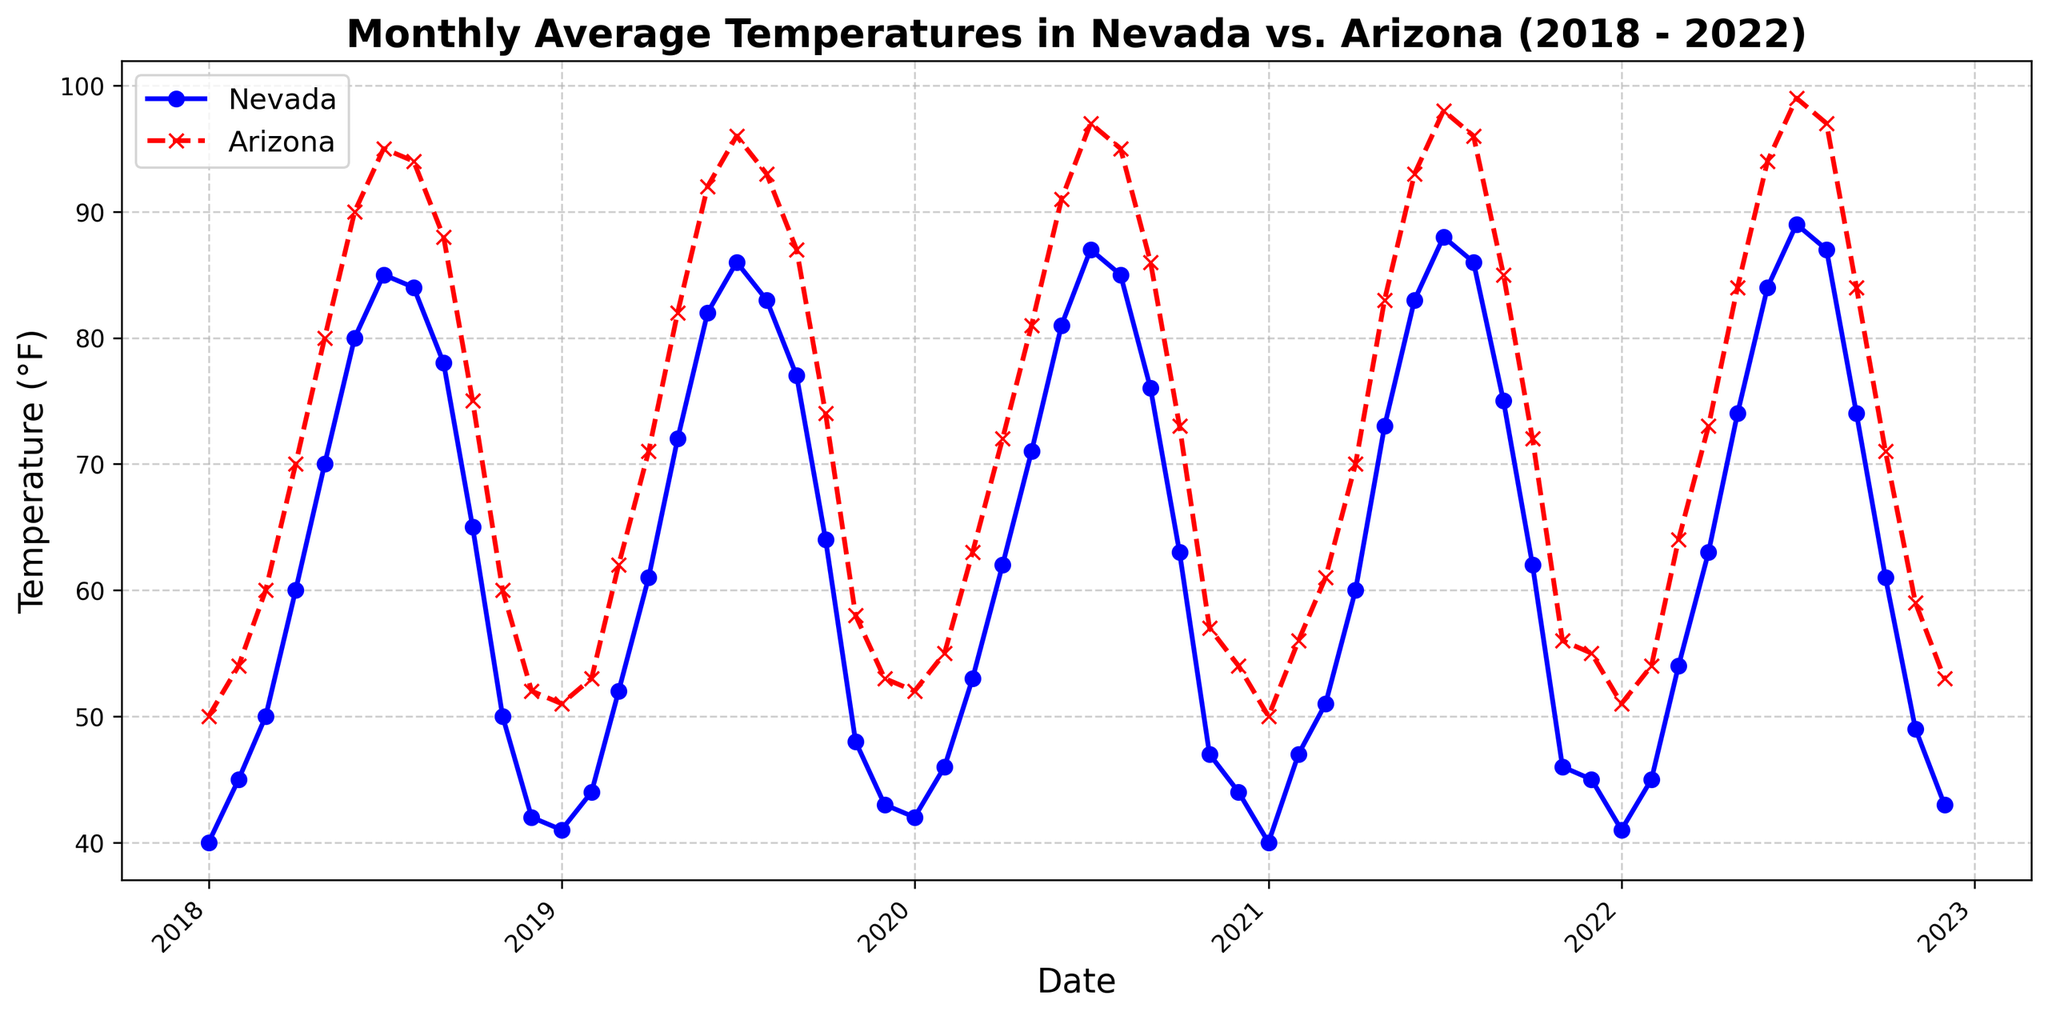Which year had the highest average temperature for Arizona in July? Look at the red 'x' marker on the plot at the July points across all the years; find the highest position. The highest red 'x' marker is in 2022, which indicates the highest temperature.
Answer: 2022 What’s the temperature difference between Nevada and Arizona in June 2020? Identify the data points for Nevada and Arizona in June 2020 on the line chart. The value for Nevada in June 2020 is 81°F, and the value for Arizona is 91°F. The difference is 91 - 81.
Answer: 10°F In which month did Nevada experience the most consistent temperatures across the five years? Evaluate the fluctuations of the blue 'o' markers for each month over the years; find the month where the blue marks are most closely aligned. January shows the least fluctuation in blue markers (around 40-42°F).
Answer: January Which state had a higher average temperature over the five years in May? Calculate the sum of May temperatures for each state, then find their averages. (Nevada: (70+72+71+73+74)/5 = 72°F; Arizona: (80+82+81+83+84)/5 = 82°F). The average for Arizona is higher.
Answer: Arizona How did the temperatures in Nevada and Arizona compare in December 2019? Look for the data points for December 2019; compare their heights. Nevada's December 2019 temperature is 43°F and Arizona’s is 53°F. Arizona’s temperature is higher.
Answer: Arizona’s temperature was higher What is the average December temperature in Nevada over the five years? Identify the December temperatures for Nevada over the years (42, 43, 44, 45, 43). Sum them and then divide by 5: (42 + 43 + 44 + 45 + 43) / 5 = 43.4
Answer: 43.4°F Which year showed the smallest temperature difference between Nevada and Arizona in June? Calculate the difference for each June, and identify the smallest. Differences are 10(Red:2018), 10(2019), 10(2020), 10(2021), 10(2022). All differences are equal.
Answer: All years (equal differences) When did both Nevada and Arizona reach their highest average temperatures in July? Check the July data points for both states; the highest values are: Nevada 2022 (89°F) and Arizona 2022 (99°F). Both peaked in July 2022.
Answer: July 2022 Which month in 2018 showed the largest temperature difference between Nevada and Arizona? Identify monthly temperature differences in 2018: Jan(10°F), Feb(9°F), Mar(10°F), Apr(10°F), May(10°F), Jun(10°F), Jul(10°F), Aug(10°F), Sep(10°F), Oct(10°F), Nov(10°F), Dec(10°F). All months have equal differences.
Answer: All months (equal differences) What is the general trend of temperatures from January to December in Arizona over the years? Observe the pattern of red 'x' markers; it starts low, peaks around July, then declines.
Answer: Increase to July, then decrease 